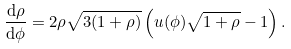<formula> <loc_0><loc_0><loc_500><loc_500>\frac { \mathrm d \rho } { \mathrm d \phi } = 2 \rho \sqrt { 3 ( 1 + \rho ) } \left ( u ( \phi ) \sqrt { 1 + \rho } - 1 \right ) .</formula> 